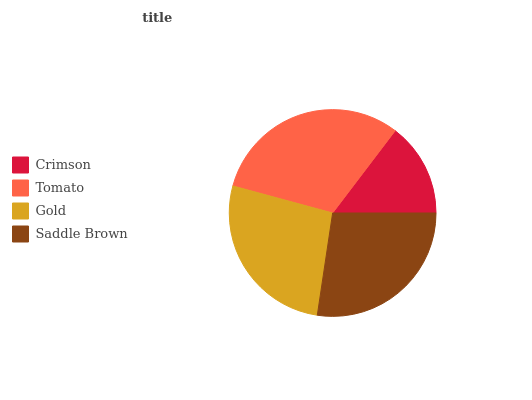Is Crimson the minimum?
Answer yes or no. Yes. Is Tomato the maximum?
Answer yes or no. Yes. Is Gold the minimum?
Answer yes or no. No. Is Gold the maximum?
Answer yes or no. No. Is Tomato greater than Gold?
Answer yes or no. Yes. Is Gold less than Tomato?
Answer yes or no. Yes. Is Gold greater than Tomato?
Answer yes or no. No. Is Tomato less than Gold?
Answer yes or no. No. Is Saddle Brown the high median?
Answer yes or no. Yes. Is Gold the low median?
Answer yes or no. Yes. Is Gold the high median?
Answer yes or no. No. Is Tomato the low median?
Answer yes or no. No. 